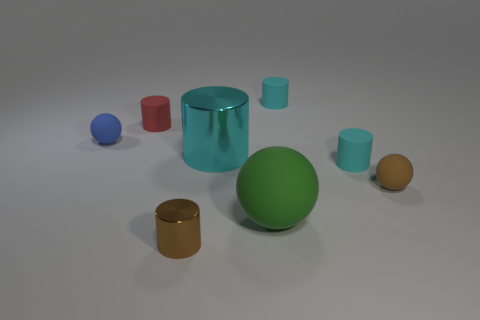There is a small cyan rubber object in front of the small blue rubber thing; does it have the same shape as the big green thing?
Offer a very short reply. No. Is there any other thing that is the same shape as the tiny red object?
Offer a very short reply. Yes. How many cylinders are either tiny red rubber things or cyan metallic things?
Ensure brevity in your answer.  2. What number of large cyan objects are there?
Offer a terse response. 1. What is the size of the rubber cylinder that is left of the large object behind the small brown matte sphere?
Give a very brief answer. Small. How many other things are the same size as the brown cylinder?
Provide a short and direct response. 5. There is a large green matte sphere; how many small brown things are to the right of it?
Your response must be concise. 1. The blue sphere is what size?
Ensure brevity in your answer.  Small. Does the tiny brown thing on the right side of the tiny brown shiny cylinder have the same material as the large object that is behind the brown ball?
Ensure brevity in your answer.  No. Is there a big thing that has the same color as the tiny shiny cylinder?
Ensure brevity in your answer.  No. 